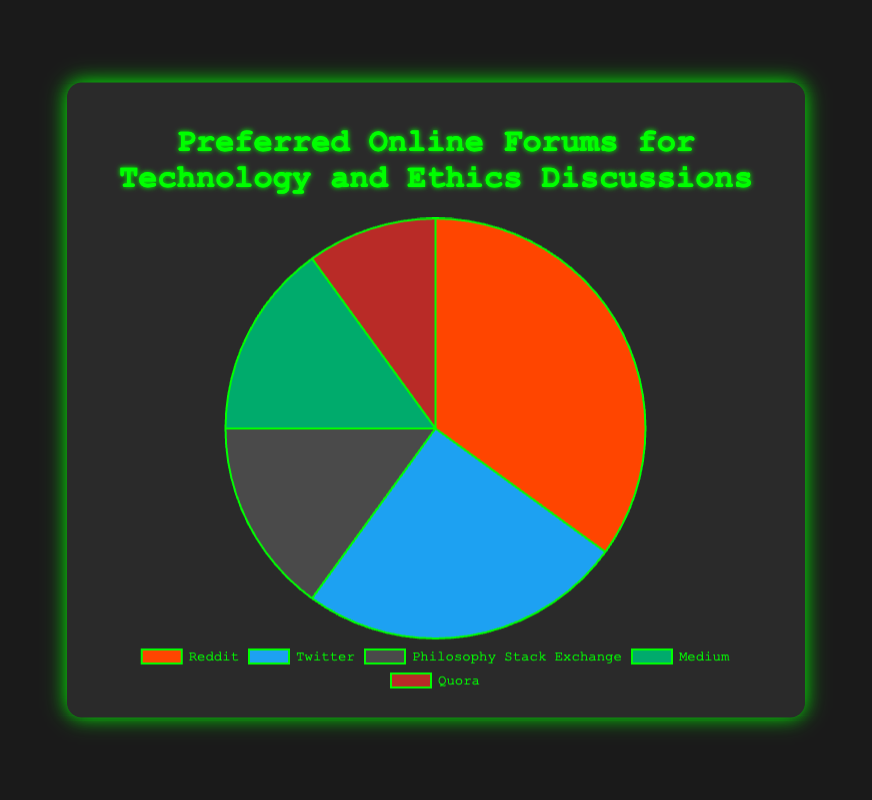What's the largest forum percentage in the pie chart? To determine the largest forum percentage, look at the pie chart and identify the segment that occupies the most space. According to the data, Reddit has the largest share at 35%.
Answer: 35% What’s the combined percentage of Medium and Quora? To find the combined percentage of Medium and Quora, simply add their individual percentages: Medium (15%) + Quora (10%). Therefore, the combined percentage is 15% + 10% = 25%.
Answer: 25% How does the percentage of Twitter compare to that of Reddit? To compare the percentages, simply look at their values. Twitter has a percentage of 25%, while Reddit has 35%. Thus, Twitter's percentage is less than Reddit's.
Answer: Twitter < Reddit Which forum has a percentage equal to that of Philosophy Stack Exchange? From the dataset, Philosophy Stack Exchange has a percentage of 15%. By comparing it with other forums, Medium also has a percentage of 15%. Therefore, Medium has the same percentage as Philosophy Stack Exchange.
Answer: Medium What is the difference between the percentage of Reddit and Quora? To find the difference, subtract Quora’s percentage from Reddit’s percentage: Reddit (35%) - Quora (10%) = 25%. So the difference is 25%.
Answer: 25% What is the total percentage represented by the three least popular forums? Add the percentages of the three least popular forums: Philosophy Stack Exchange (15%) + Medium (15%) + Quora (10%). This totals 15% + 15% + 10% = 40%.
Answer: 40% How many forums have a percentage higher than 20%? By checking the dataset, only Reddit (35%) and Twitter (25%) have percentages higher than 20%. Therefore, there are 2 forums with percentages higher than 20%.
Answer: 2 What color represents the forum with the lowest percentage? To identify the color of the forum with the lowest percentage, look for the smallest segment, which is Quora at 10%. The color representing Quora is red.
Answer: Red 